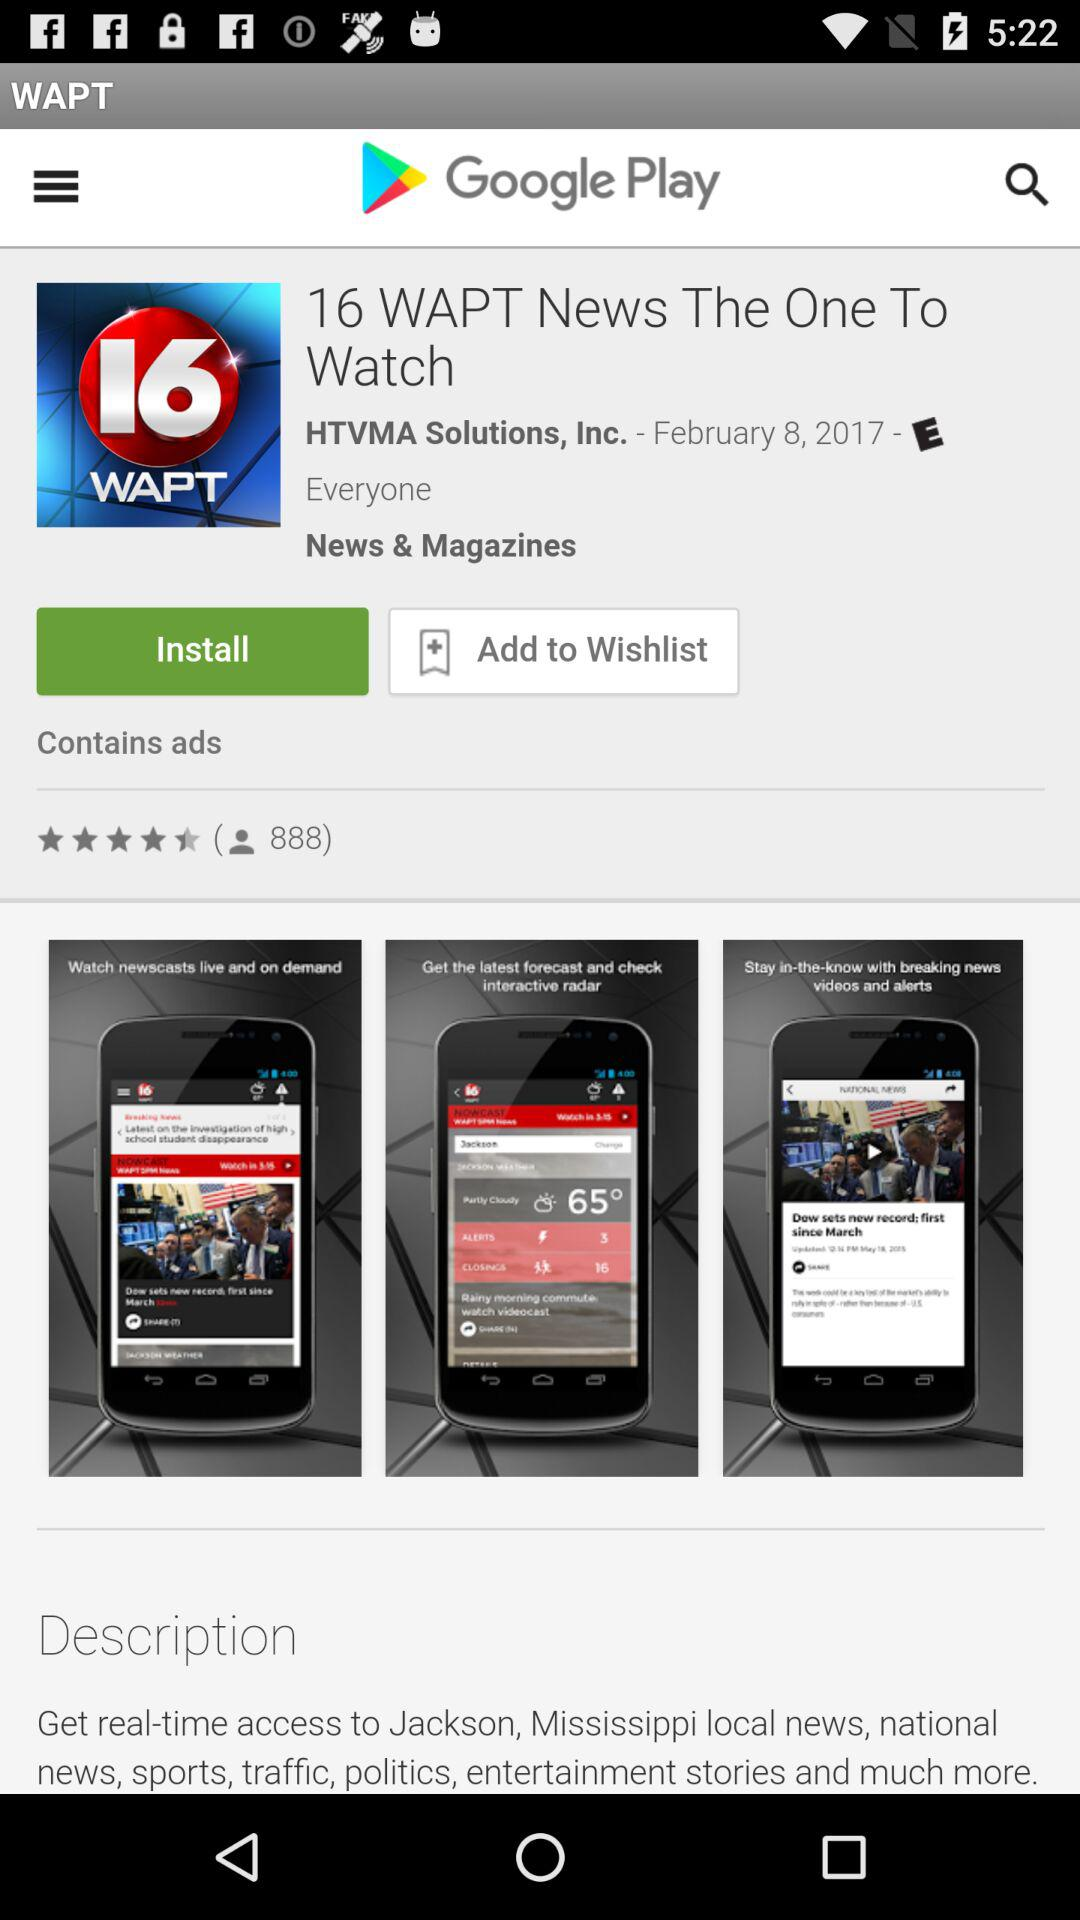What is the name of the main application in which other application is shown? The name of the main application is "Google Play Store". 